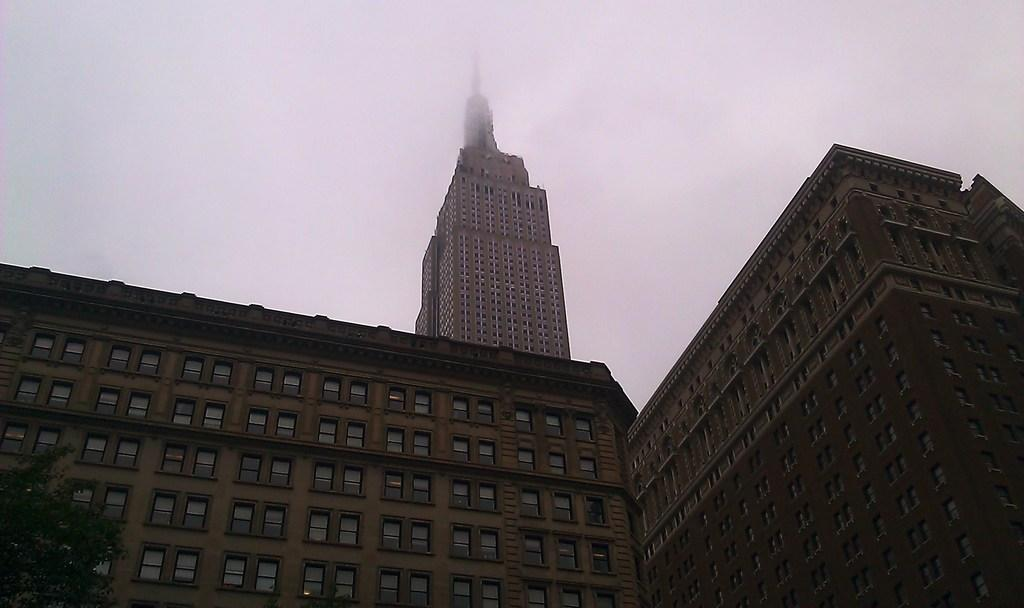What type of structures are present in the image? There are buildings in the image. What are some features of the buildings? The buildings have walls and windows. What can be seen in the background of the image? The sky is visible in the background of the image. How many passengers are visible inside the buildings in the image? There are no passengers visible inside the buildings in the image, as it only shows the exterior of the structures. 